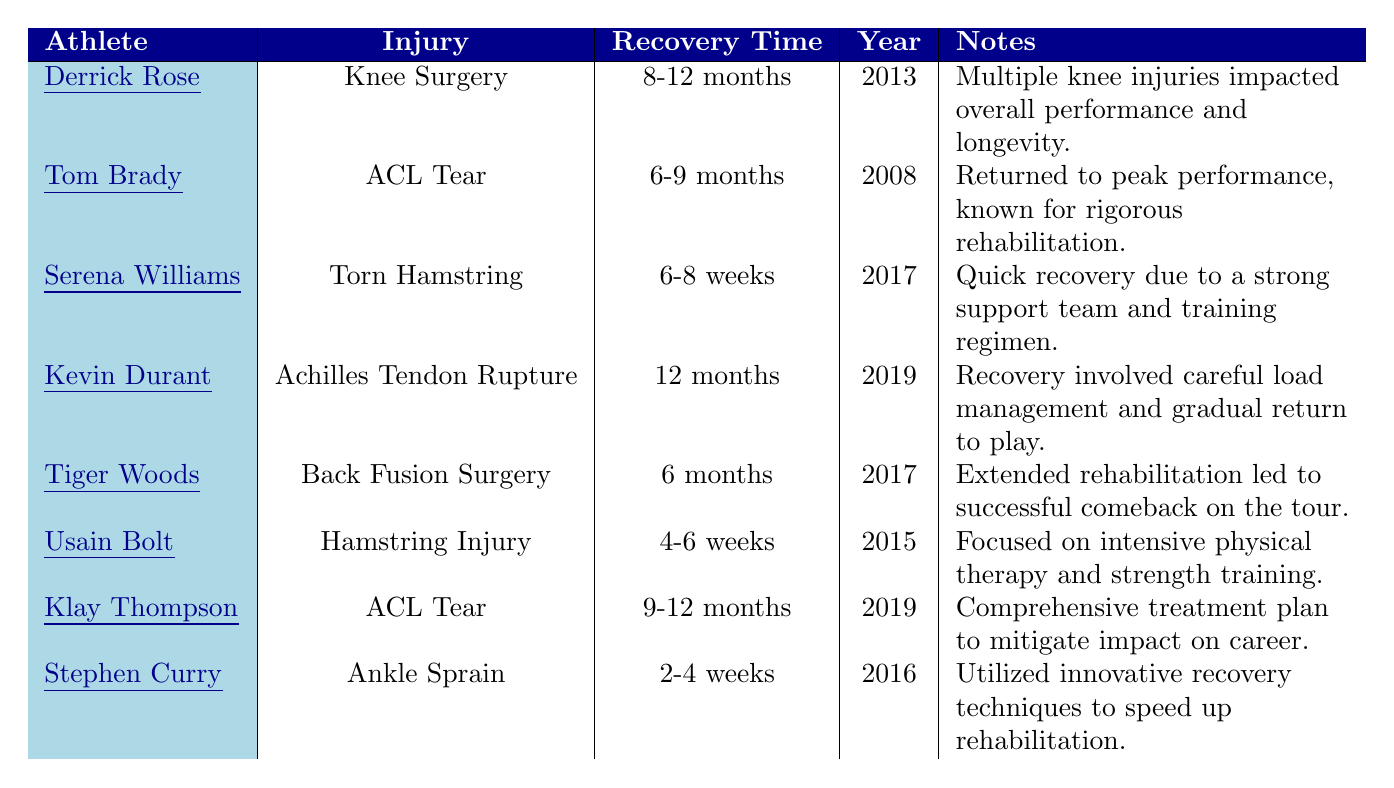What is the maximum recovery time listed in the table? The maximum recovery time listed is 12 months, which corresponds to Kevin Durant's Achilles Tendon Rupture in 2019.
Answer: 12 months Which athlete had the shortest recovery time? Stephen Curry had the shortest recovery time of 2-4 weeks for an ankle sprain in 2016.
Answer: 2-4 weeks How many athletes had ACL tears and what were their recovery times? There are two athletes with ACL tears: Tom Brady with a recovery time of 6-9 months and Klay Thompson with a recovery time of 9-12 months.
Answer: 2 athletes: 6-9 months and 9-12 months True or false: Tiger Woods had the longest recovery time for his injury. This statement is false; Kevin Durant had the longest recovery time of 12 months for his Achilles Tendon Rupture.
Answer: False What was the average recovery time for injuries related to 'Knee Surgery' and 'ACL Tear'? Derrick Rose's recovery for Knee Surgery is 8-12 months and Tom Brady's and Klay Thompson's for ACL Tears are 6-9 months and 9-12 months, respectively. The average for Knee Surgery is 10 months and for ACL Tear is (6.5 + 10.5) / 2 = 8.5 months. Thus, the overall average should be (10 + 8.5) / 2 = 9.25 months.
Answer: 9.25 months Name the athlete who underwent back fusion surgery and the recovery time for that injury. The athlete who underwent back fusion surgery is Tiger Woods, and his recovery time was 6 months.
Answer: Tiger Woods, 6 months Which athlete had a torn hamstring, and how long did it take to recover? Serena Williams had a torn hamstring, which took her 6-8 weeks to recover.
Answer: Serena Williams, 6-8 weeks What were the recovery times for hamstring injuries listed in the table? Usain Bolt had a hamstring injury with a recovery time of 4-6 weeks, and Serena Williams had a torn hamstring with a recovery time of 6-8 weeks.
Answer: 4-6 weeks and 6-8 weeks Among the athletes listed, who returned to peak performance after injury? Tom Brady returned to peak performance after recovering from his ACL tear.
Answer: Tom Brady Identify the year when Kevin Durant had his Achilles tendon rupture. Kevin Durant had his Achilles tendon rupture in 2019.
Answer: 2019 Which athlete's recovery involved 'careful load management'? Kevin Durant's recovery involved careful load management and gradual return to play after his Achilles tendon rupture.
Answer: Kevin Durant 